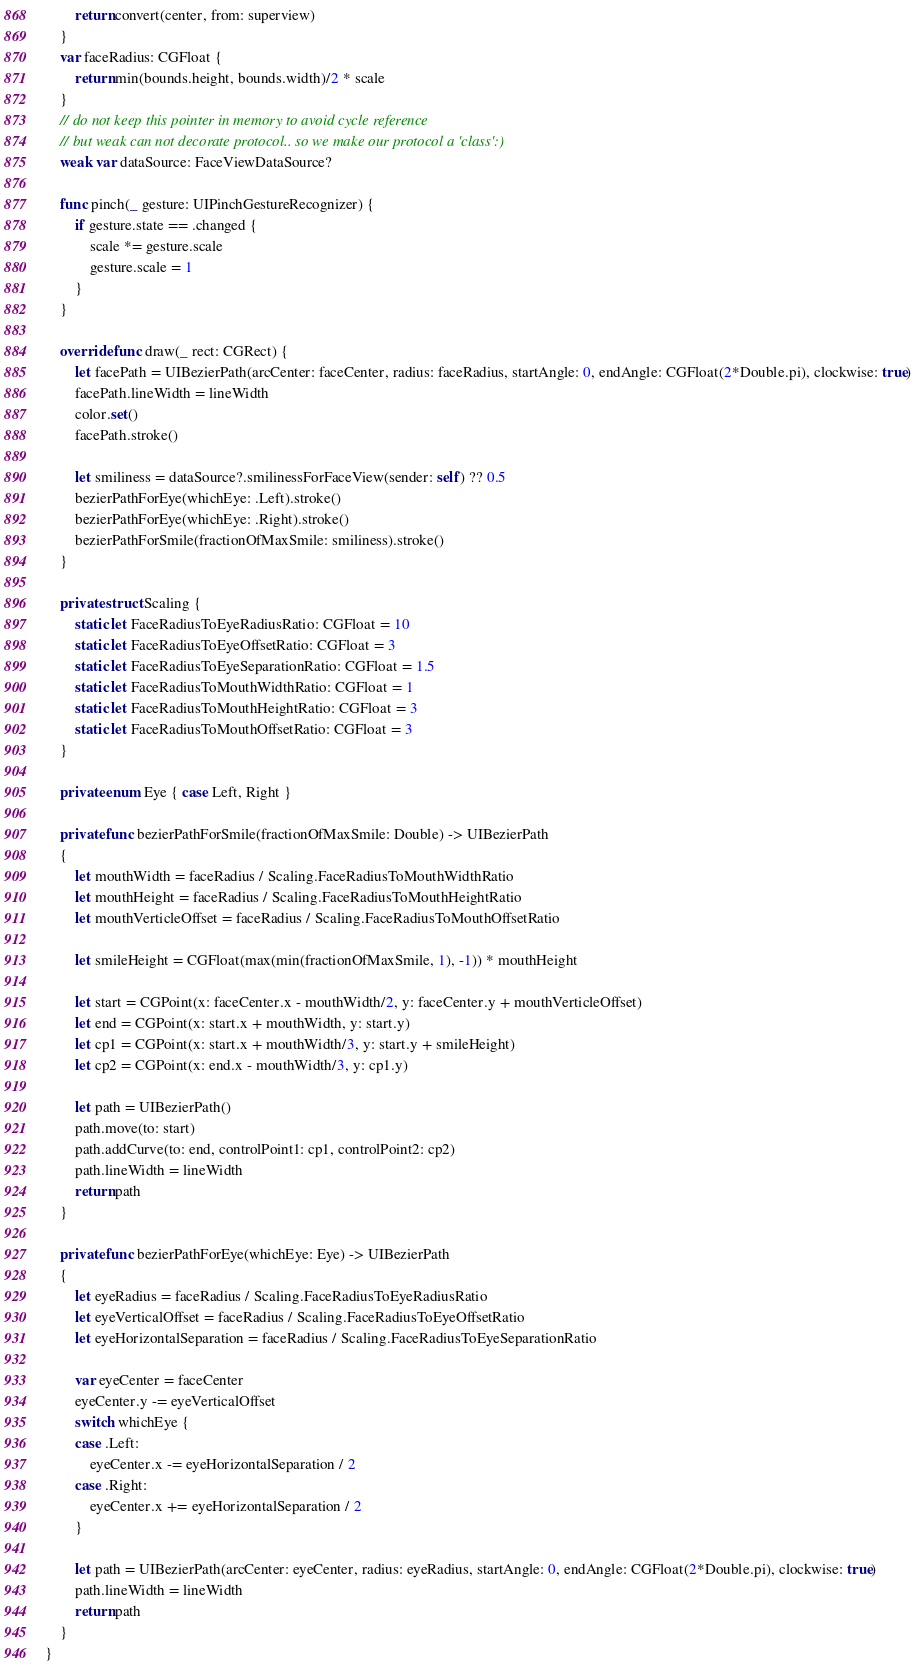Convert code to text. <code><loc_0><loc_0><loc_500><loc_500><_Swift_>        return convert(center, from: superview)
    }
    var faceRadius: CGFloat {
        return min(bounds.height, bounds.width)/2 * scale
    }
    // do not keep this pointer in memory to avoid cycle reference
    // but weak can not decorate protocol.. so we make our protocol a 'class':)
    weak var dataSource: FaceViewDataSource?
    
    func pinch(_ gesture: UIPinchGestureRecognizer) {
        if gesture.state == .changed {
            scale *= gesture.scale
            gesture.scale = 1
        }
    }
    
    override func draw(_ rect: CGRect) {
        let facePath = UIBezierPath(arcCenter: faceCenter, radius: faceRadius, startAngle: 0, endAngle: CGFloat(2*Double.pi), clockwise: true)
        facePath.lineWidth = lineWidth
        color.set()
        facePath.stroke()
        
        let smiliness = dataSource?.smilinessForFaceView(sender: self) ?? 0.5
        bezierPathForEye(whichEye: .Left).stroke()
        bezierPathForEye(whichEye: .Right).stroke()
        bezierPathForSmile(fractionOfMaxSmile: smiliness).stroke()
    }
    
    private struct Scaling {
        static let FaceRadiusToEyeRadiusRatio: CGFloat = 10
        static let FaceRadiusToEyeOffsetRatio: CGFloat = 3
        static let FaceRadiusToEyeSeparationRatio: CGFloat = 1.5
        static let FaceRadiusToMouthWidthRatio: CGFloat = 1
        static let FaceRadiusToMouthHeightRatio: CGFloat = 3
        static let FaceRadiusToMouthOffsetRatio: CGFloat = 3
    }
    
    private enum Eye { case Left, Right }
    
    private func bezierPathForSmile(fractionOfMaxSmile: Double) -> UIBezierPath
    {
        let mouthWidth = faceRadius / Scaling.FaceRadiusToMouthWidthRatio
        let mouthHeight = faceRadius / Scaling.FaceRadiusToMouthHeightRatio
        let mouthVerticleOffset = faceRadius / Scaling.FaceRadiusToMouthOffsetRatio
        
        let smileHeight = CGFloat(max(min(fractionOfMaxSmile, 1), -1)) * mouthHeight
        
        let start = CGPoint(x: faceCenter.x - mouthWidth/2, y: faceCenter.y + mouthVerticleOffset)
        let end = CGPoint(x: start.x + mouthWidth, y: start.y)
        let cp1 = CGPoint(x: start.x + mouthWidth/3, y: start.y + smileHeight)
        let cp2 = CGPoint(x: end.x - mouthWidth/3, y: cp1.y)
        
        let path = UIBezierPath()
        path.move(to: start)
        path.addCurve(to: end, controlPoint1: cp1, controlPoint2: cp2)
        path.lineWidth = lineWidth
        return path
    }
    
    private func bezierPathForEye(whichEye: Eye) -> UIBezierPath
    {
        let eyeRadius = faceRadius / Scaling.FaceRadiusToEyeRadiusRatio
        let eyeVerticalOffset = faceRadius / Scaling.FaceRadiusToEyeOffsetRatio
        let eyeHorizontalSeparation = faceRadius / Scaling.FaceRadiusToEyeSeparationRatio
        
        var eyeCenter = faceCenter
        eyeCenter.y -= eyeVerticalOffset
        switch whichEye {
        case .Left:
            eyeCenter.x -= eyeHorizontalSeparation / 2
        case .Right:
            eyeCenter.x += eyeHorizontalSeparation / 2
        }
        
        let path = UIBezierPath(arcCenter: eyeCenter, radius: eyeRadius, startAngle: 0, endAngle: CGFloat(2*Double.pi), clockwise: true)
        path.lineWidth = lineWidth
        return path
    }
}
</code> 